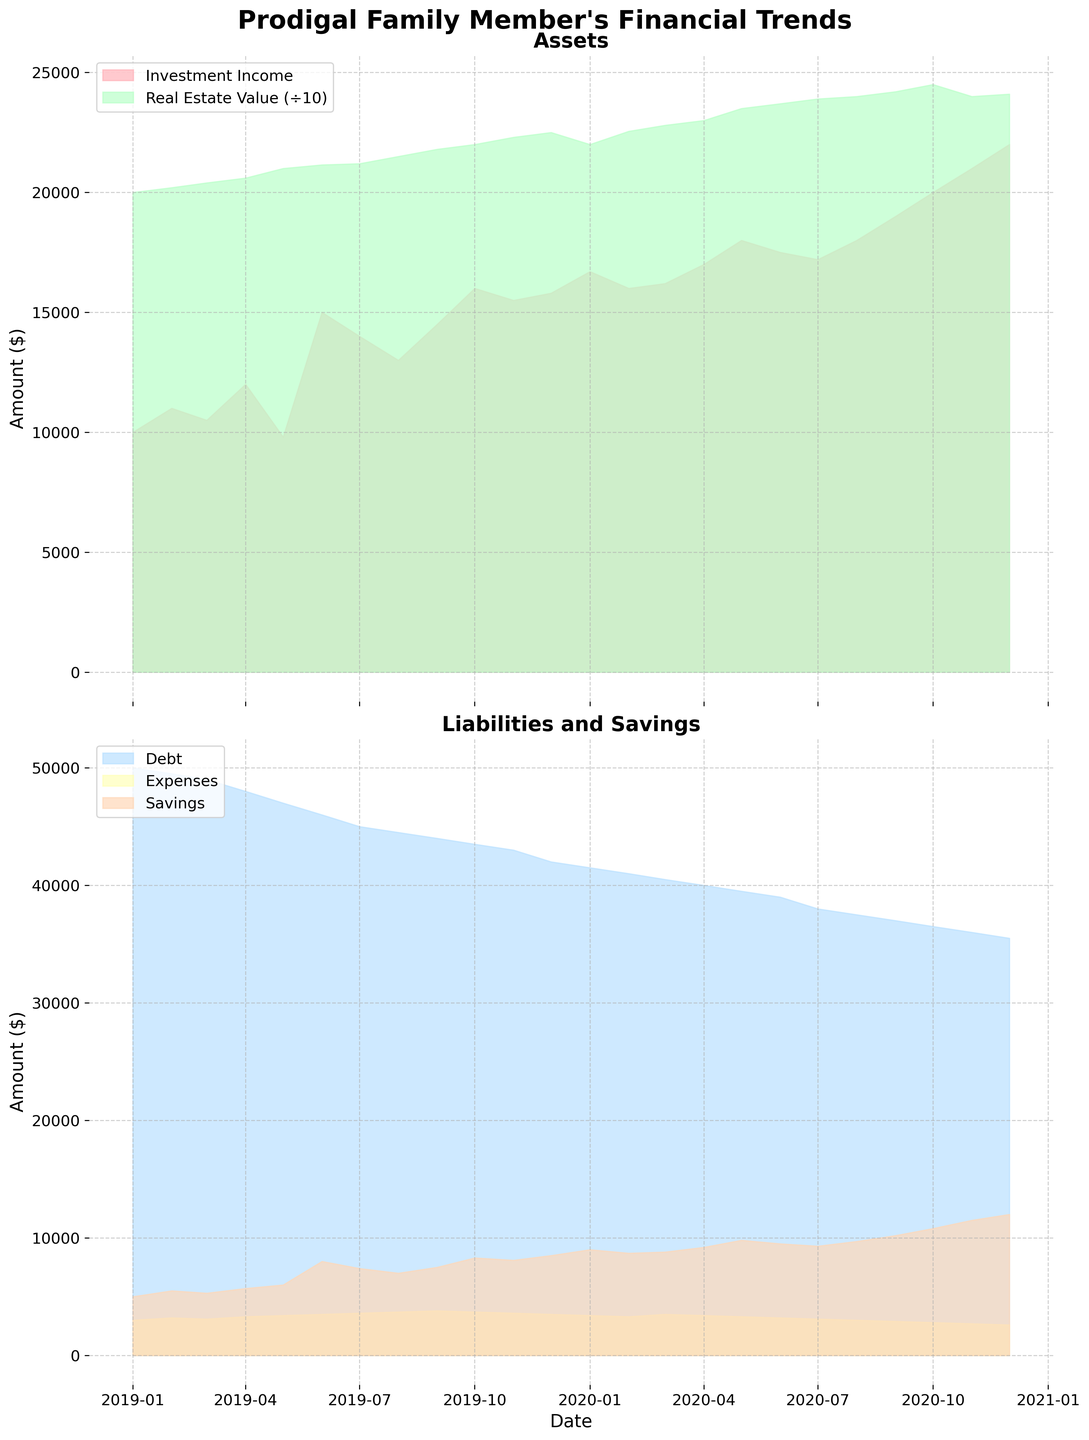what's the title of the figure? The title is located at the top of the figure. In this case, the title reads "Prodigal Family Member's Financial Trends".
Answer: Prodigal Family Member's Financial Trends what elements are shown in the upper subplot? The upper subplot displays two elements visualized through area charts: "Investment Income" and "Real Estate Value".
Answer: Investment Income and Real Estate Value how does the investment income trend look from the start to the end of the period? The trend can be observed by examining the upper subplot. The Investment Income starts at $10,000 in January 2019 and rises steadily, reaching $22,000 by December 2020.
Answer: It rises steadily what is the largest increase in Real Estate Value shown in the figure? To find the largest increase, look at the monthly values of Real Estate Value in the upper subplot and find the difference between their successive values. The largest increase appears between May 2020 ($235,000) and June 2020 ($237,000), which is an increase of $2,000.
Answer: $2,000 how do Debt and Savings compare in January 2019? To compare Debt and Savings in January 2019, refer to the lower subplot. In January 2019, Debt is $50,000, while Savings is $5,000.
Answer: Debt is greater than Savings which category in the lower subplot exhibits the most stable behavior over time? The most stable category can be identified by observing the area chart in the lower subplot. Expenses fluctuate very little compared to Debt and Savings.
Answer: Expenses what is the trend observed in Savings from the start to the end of the period? By analyzing the lower subplot, Savings starts at $5,000 in January 2019 and rises steadily to $12,000 by December 2020. This indicates a clear increasing trend over the period.
Answer: Increasing trend how does the Real Estate Value compare to Investment Income in October 2020 after scaling? Real Estate Value is divided by 10 for better visual comparison with Investment Income. In October 2020, scaled Real Estate Value is $245,000 / 10 = $24,500, which is higher than Investment Income ($20,000).
Answer: Real Estate Value is higher which does the figure suggest would have more impact on reducing overall liabilities, reducing Debt or Expenses? By comparing the areas of Debt and Expenses in the lower subplot, it's evident that Debt occupies a larger area than Expenses. Therefore, reducing Debt would have a more significant impact on reducing overall liabilities.
Answer: Reducing Debt what's the minimum Savings value and in which month does it occur? Observation of the lower subplot shows that the minimum Savings value is $5,000 in January 2019.
Answer: $5,000, January 2019 